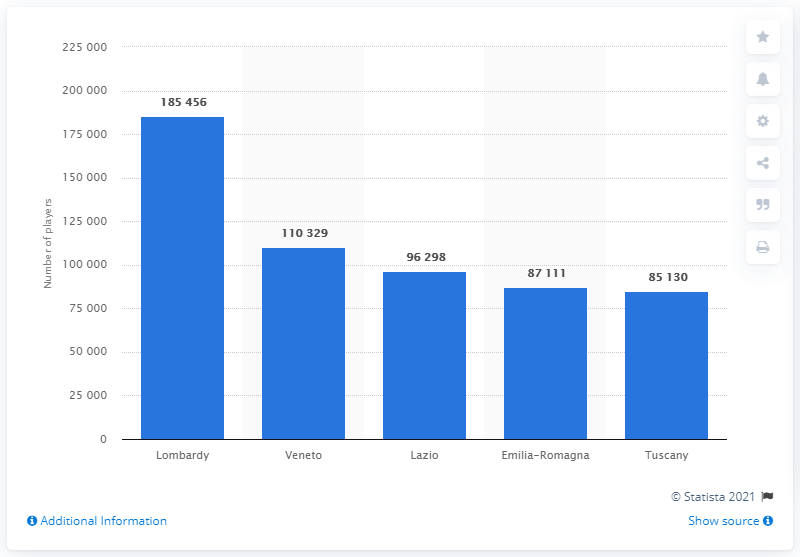List a handful of essential elements in this visual. In the 2018/2019 season, Lombardy had a total of 185,456 players. In the year 1854, it is estimated that the total number of amateur football players in the regions of Veneto and Lazio was 185,456. According to the data collected in the 2018/2019 season, Lombardy had the highest number of amateur and youth soccer players in Italy. 